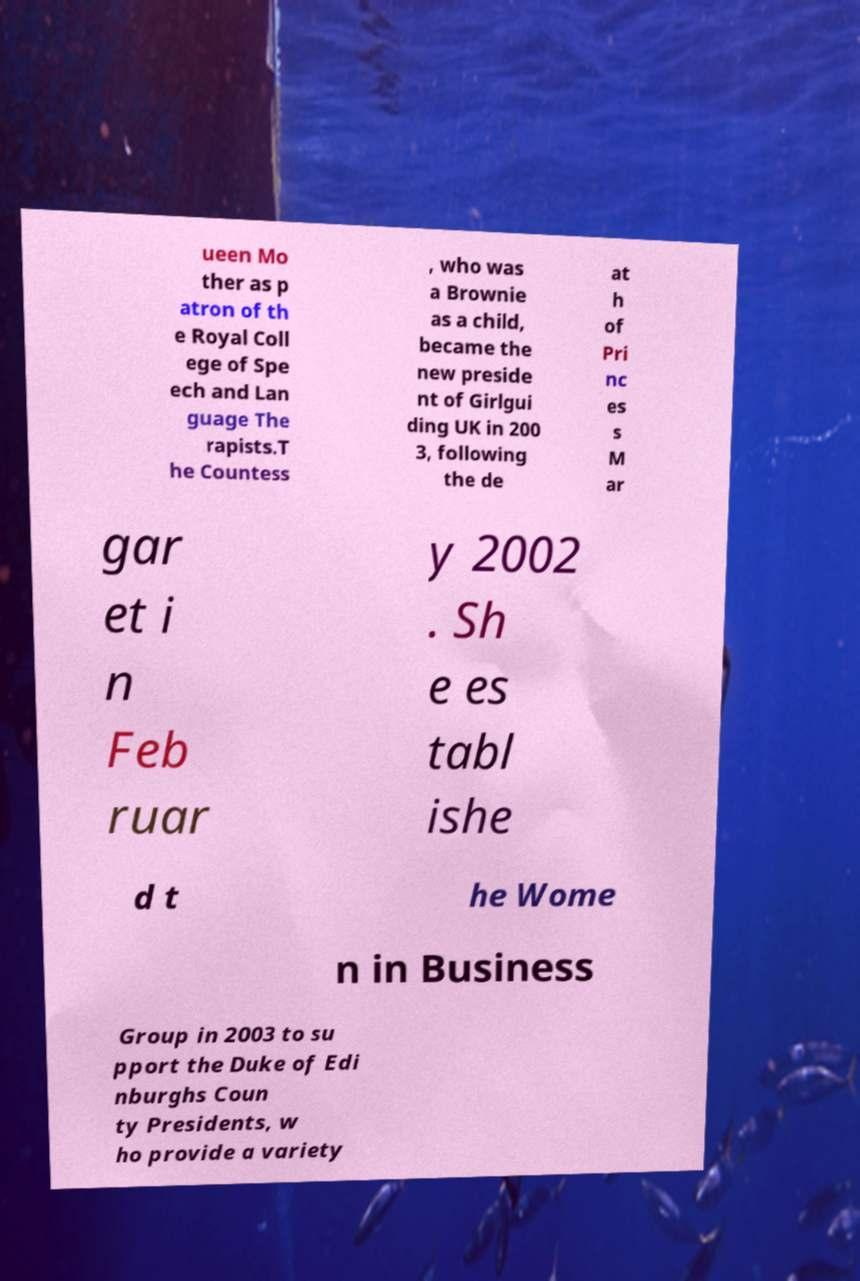For documentation purposes, I need the text within this image transcribed. Could you provide that? ueen Mo ther as p atron of th e Royal Coll ege of Spe ech and Lan guage The rapists.T he Countess , who was a Brownie as a child, became the new preside nt of Girlgui ding UK in 200 3, following the de at h of Pri nc es s M ar gar et i n Feb ruar y 2002 . Sh e es tabl ishe d t he Wome n in Business Group in 2003 to su pport the Duke of Edi nburghs Coun ty Presidents, w ho provide a variety 